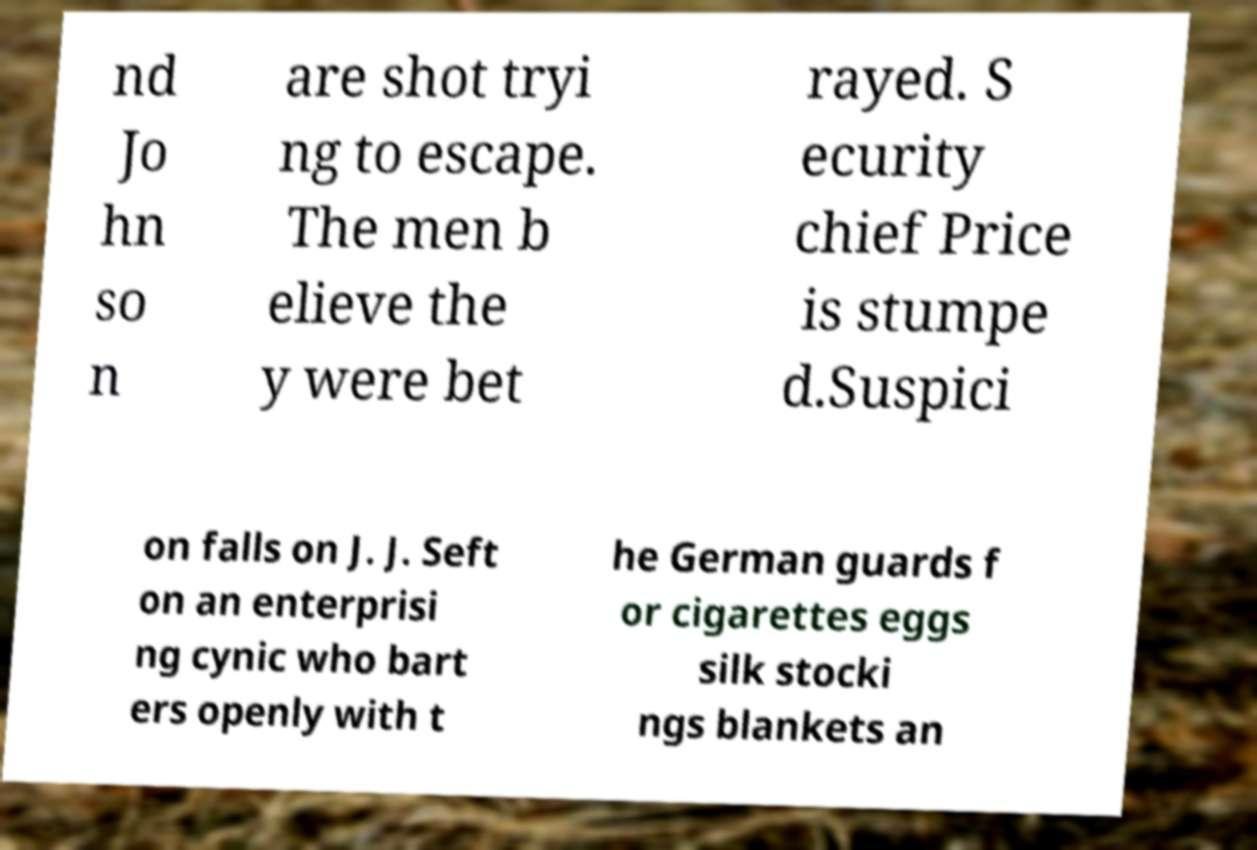Please read and relay the text visible in this image. What does it say? nd Jo hn so n are shot tryi ng to escape. The men b elieve the y were bet rayed. S ecurity chief Price is stumpe d.Suspici on falls on J. J. Seft on an enterprisi ng cynic who bart ers openly with t he German guards f or cigarettes eggs silk stocki ngs blankets an 